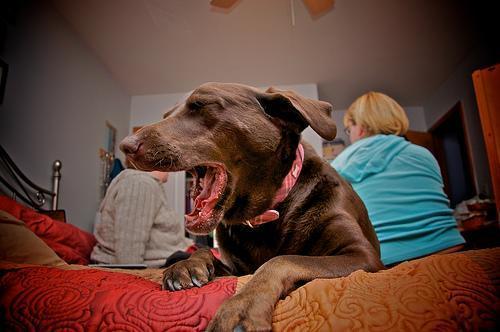How many people are there?
Give a very brief answer. 2. How many of the zebras are standing up?
Give a very brief answer. 0. 